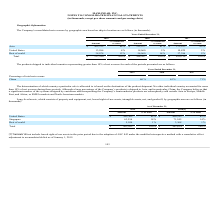From Maxlinear's financial document, What was the respective amount in 2019 and 2018 from Singapore? The document shows two values: 63,556 and 71,945 (in thousands). From the document: "Singapore 63,556 14% 71,945 14% Singapore 63,556 14% 71,945 14%..." Also, What was the respective amount in 2019 and 2018 from United States? The document shows two values: $385,302 and $426,321 (in thousands). From the document: "United States $ 385,302 85% $ 426,321 85% United States $ 385,302 85% $ 426,321 85%..." Also, What was the percentage of total from Singapore in 2019? According to the financial document, 14 (percentage). The relevant text states: "Singapore 63,556 14% 71,945 14%..." Also, can you calculate: What was the change in the United States amount from 2018 to 2019? Based on the calculation: 385,302 - 426,321, the result is -41019 (in thousands). This is based on the information: "United States $ 385,302 85% $ 426,321 85% United States $ 385,302 85% $ 426,321 85%..." The key data points involved are: 385,302, 426,321. Also, can you calculate: What was the average amount from Singapore in 2018 and 2019? To answer this question, I need to perform calculations using the financial data. The calculation is: (63,556 + 71,945) / 2, which equals 67750.5 (in thousands). This is based on the information: "Singapore 63,556 14% 71,945 14% Singapore 63,556 14% 71,945 14%..." The key data points involved are: 63,556, 71,945. Also, can you calculate: What was the average total amount in 2018 and 2019? To answer this question, I need to perform calculations using the financial data. The calculation is: (453,892 + 501,634) / 2, which equals 477763 (in thousands). This is based on the information: "Total $ 453,892 100% $ 501,634 100% Total $ 453,892 100% $ 501,634 100%..." The key data points involved are: 453,892, 501,634. 